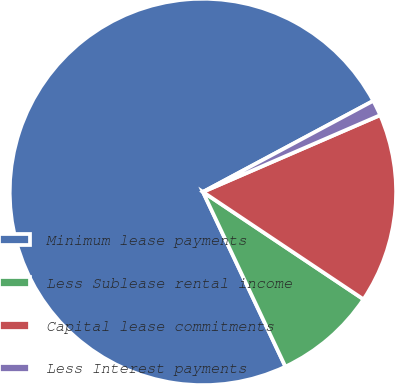<chart> <loc_0><loc_0><loc_500><loc_500><pie_chart><fcel>Minimum lease payments<fcel>Less Sublease rental income<fcel>Capital lease commitments<fcel>Less Interest payments<nl><fcel>74.21%<fcel>8.6%<fcel>15.89%<fcel>1.31%<nl></chart> 